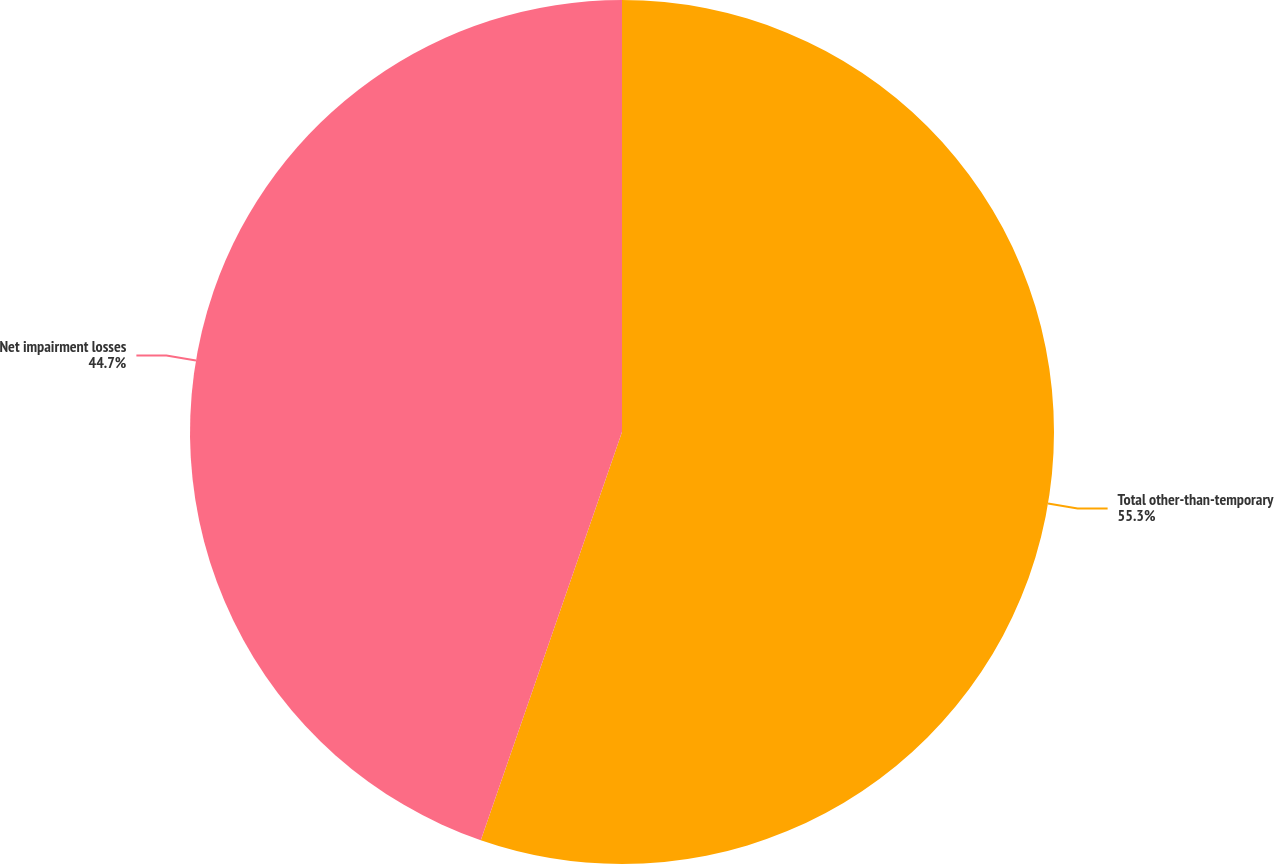Convert chart. <chart><loc_0><loc_0><loc_500><loc_500><pie_chart><fcel>Total other-than-temporary<fcel>Net impairment losses<nl><fcel>55.3%<fcel>44.7%<nl></chart> 